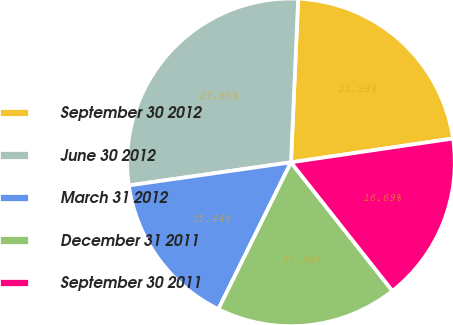Convert chart to OTSL. <chart><loc_0><loc_0><loc_500><loc_500><pie_chart><fcel>September 30 2012<fcel>June 30 2012<fcel>March 31 2012<fcel>December 31 2011<fcel>September 30 2011<nl><fcel>21.98%<fcel>27.95%<fcel>15.44%<fcel>17.94%<fcel>16.69%<nl></chart> 